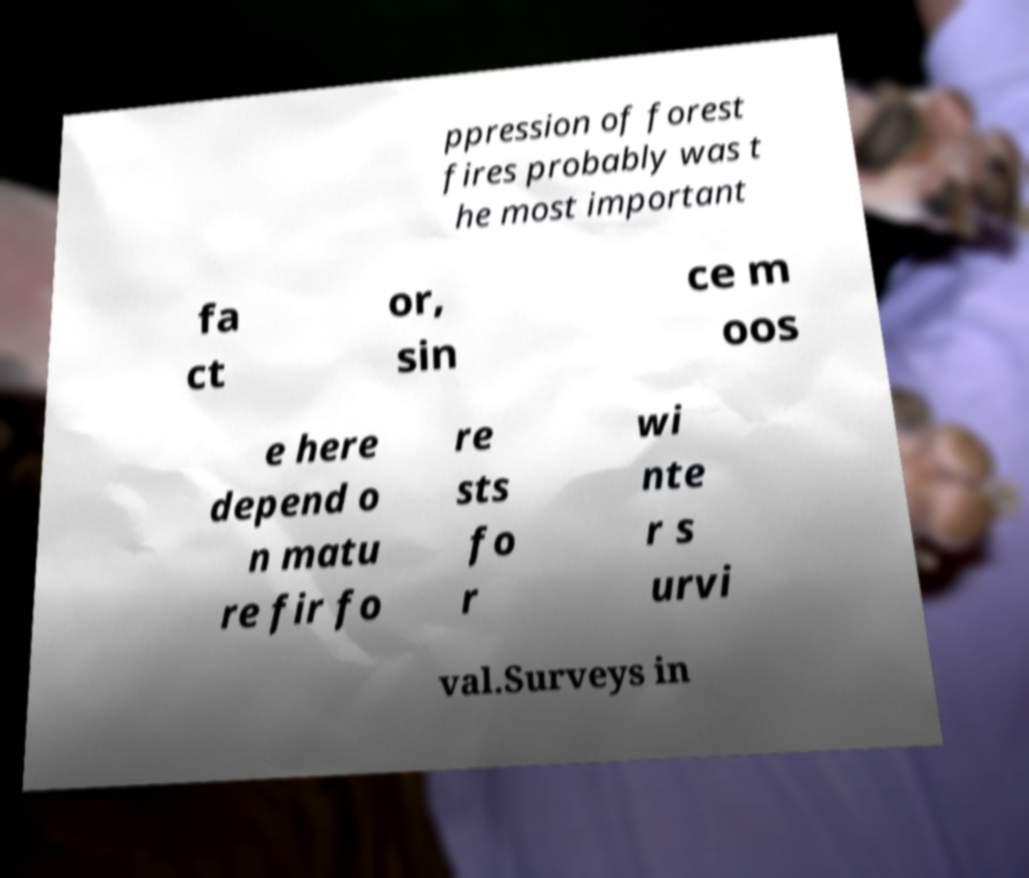Could you extract and type out the text from this image? ppression of forest fires probably was t he most important fa ct or, sin ce m oos e here depend o n matu re fir fo re sts fo r wi nte r s urvi val.Surveys in 